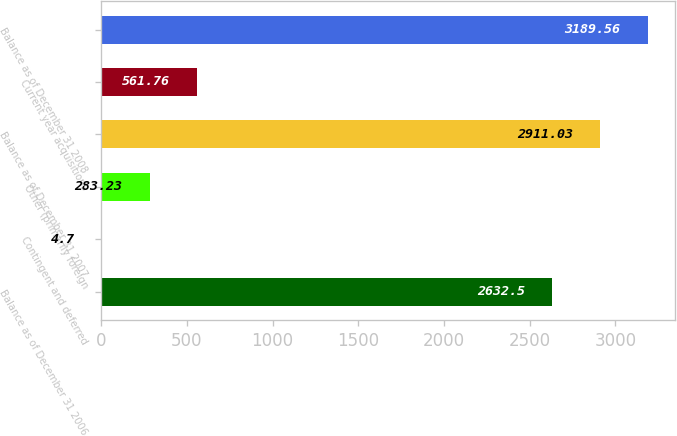Convert chart to OTSL. <chart><loc_0><loc_0><loc_500><loc_500><bar_chart><fcel>Balance as of December 31 2006<fcel>Contingent and deferred<fcel>Other (primarily foreign<fcel>Balance as of December 31 2007<fcel>Current year acquisitions<fcel>Balance as of December 31 2008<nl><fcel>2632.5<fcel>4.7<fcel>283.23<fcel>2911.03<fcel>561.76<fcel>3189.56<nl></chart> 